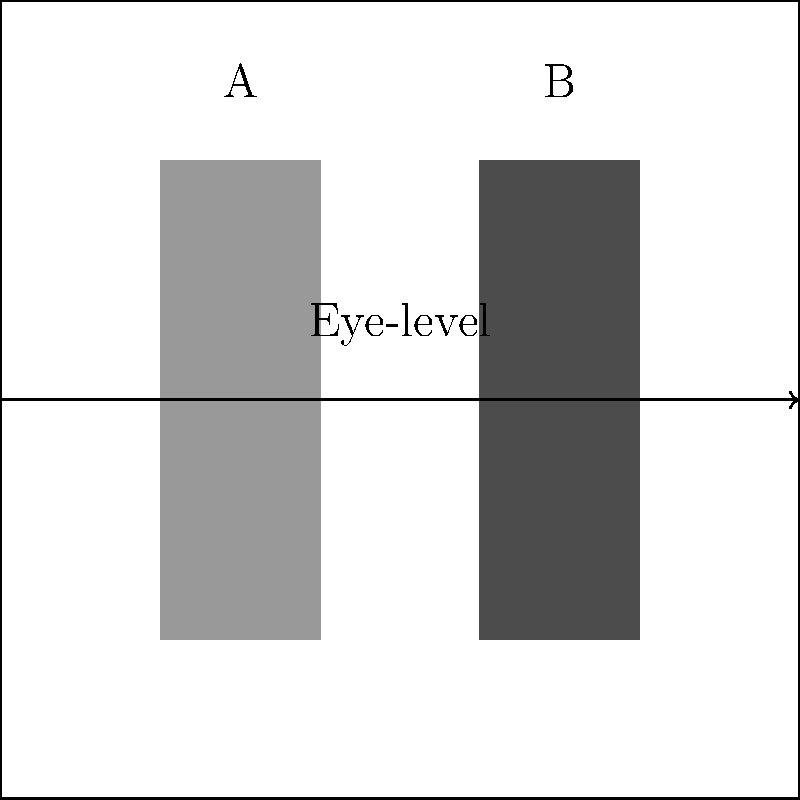In the diagram above, two characters (A and B) are framed within a shot. Character A is positioned closer to the left edge, while Character B is closer to the right. Considering the principles of visual composition in film, what does this framing potentially suggest about the characters' roles or power dynamics in the scene? To analyze this framing, we need to consider several factors:

1. Rule of thirds: The frame is divided into thirds both vertically and horizontally. Characters placed on these lines or their intersections are typically given more visual importance.

2. Visual weight: Objects closer to the edges of the frame often carry more visual weight than those in the center.

3. Left-right reading: In Western cultures, we tend to read images from left to right, similar to text.

4. Power dynamics: Characters placed higher in the frame or occupying more space are often perceived as more powerful or dominant.

Considering these principles:

1. Character A is positioned on the left third of the frame, which is typically where the eye goes first in Western visual culture.

2. Character B is positioned on the right third of the frame, which is often where the eye ends up, potentially suggesting a conclusion or resolution.

3. Both characters are at the same eye-level, indicating a potential equality in status or power.

4. Character A's darker shading could suggest they are in the foreground, potentially making them more prominent.

5. The equal size of both characters suggests neither is being diminished or elevated in terms of importance through scale.

Given this analysis, the framing suggests a dynamic where Character A might be introduced or established first, potentially as a protagonist or primary focus, while Character B might represent a goal, conflict, or resolution. However, their equal eye-level and size indicate a balanced power dynamic between them.
Answer: Character A as initial focus or protagonist, Character B as goal/conflict/resolution, with balanced power dynamic 